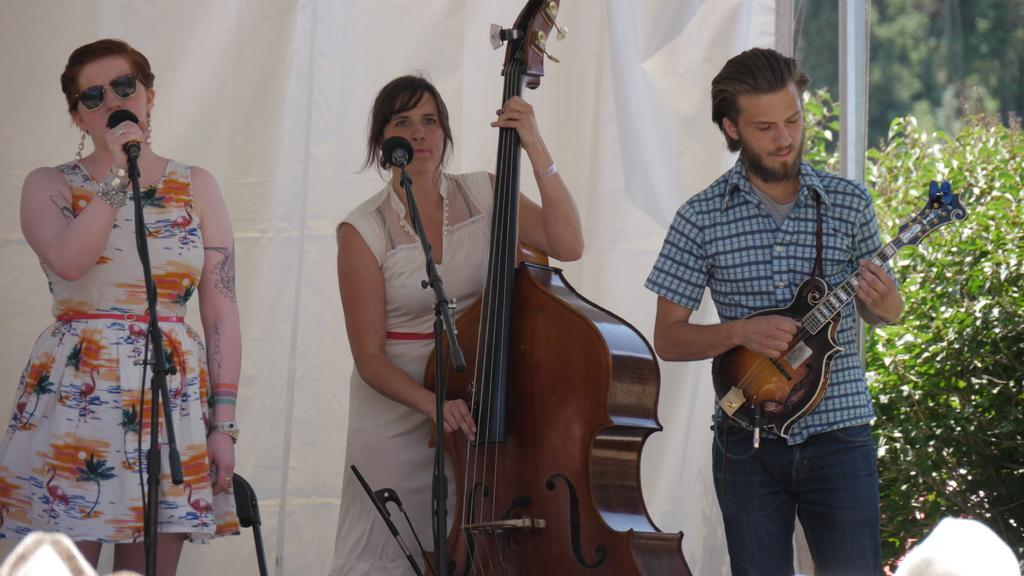What is the woman in the image doing? The woman is singing in the image. What is the woman holding while singing? The woman is holding a microphone. Are there any other musicians in the image? Yes, there is a woman playing the guitar and a man playing the guitar in the image. What type of oil is being used by the woman playing the guitar in the image? There is no oil present in the image, and the woman playing the guitar is not using any oil. 